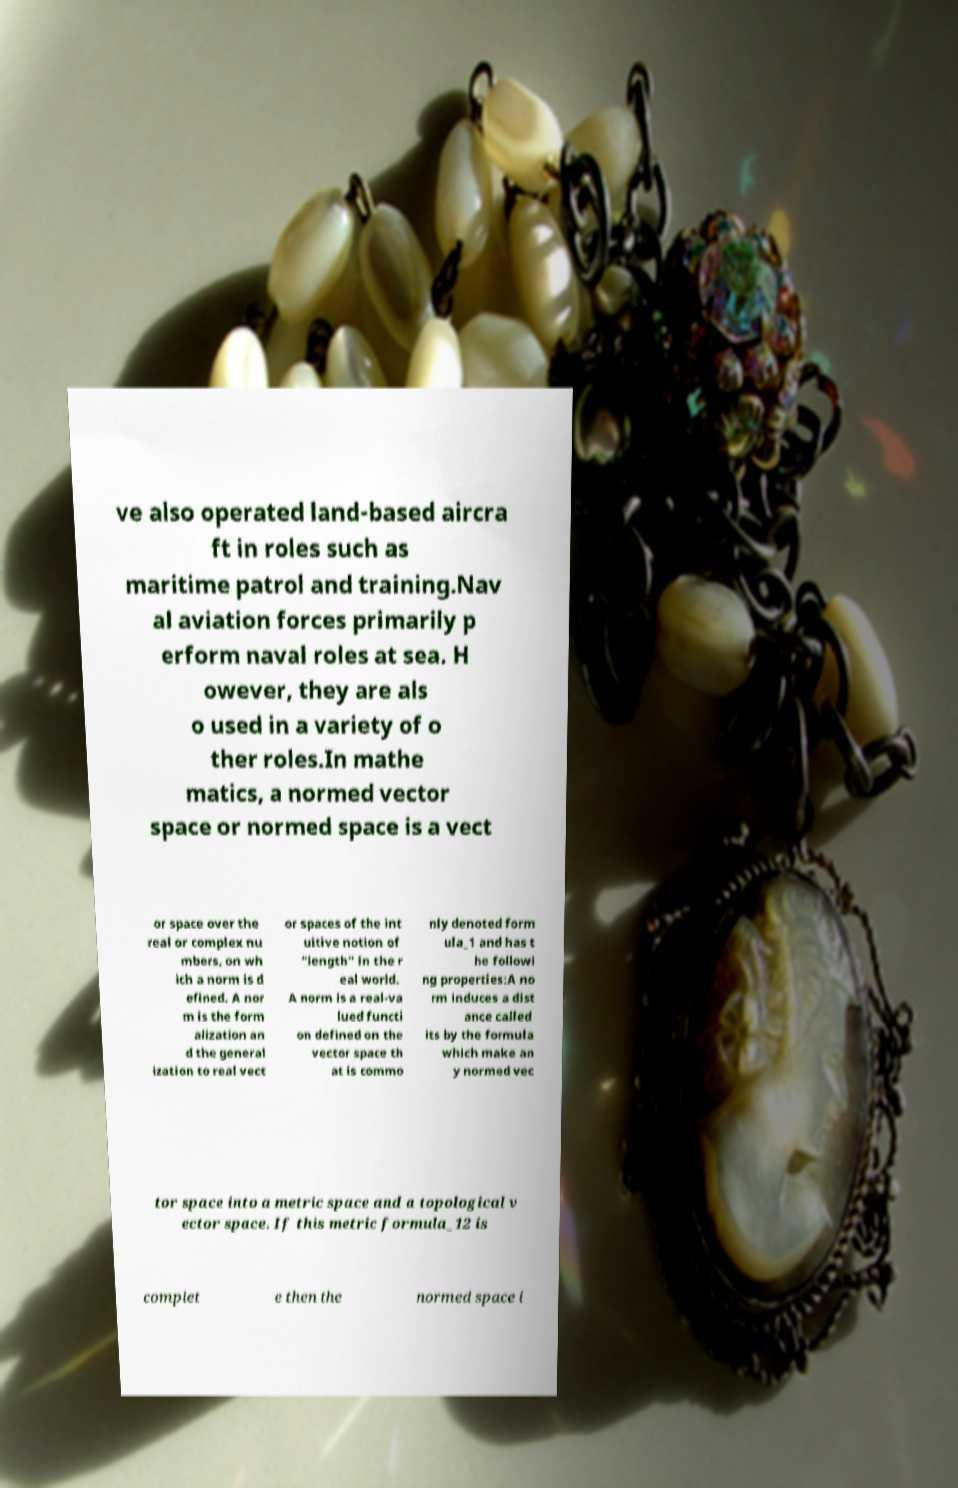I need the written content from this picture converted into text. Can you do that? ve also operated land-based aircra ft in roles such as maritime patrol and training.Nav al aviation forces primarily p erform naval roles at sea. H owever, they are als o used in a variety of o ther roles.In mathe matics, a normed vector space or normed space is a vect or space over the real or complex nu mbers, on wh ich a norm is d efined. A nor m is the form alization an d the general ization to real vect or spaces of the int uitive notion of "length" in the r eal world. A norm is a real-va lued functi on defined on the vector space th at is commo nly denoted form ula_1 and has t he followi ng properties:A no rm induces a dist ance called its by the formula which make an y normed vec tor space into a metric space and a topological v ector space. If this metric formula_12 is complet e then the normed space i 